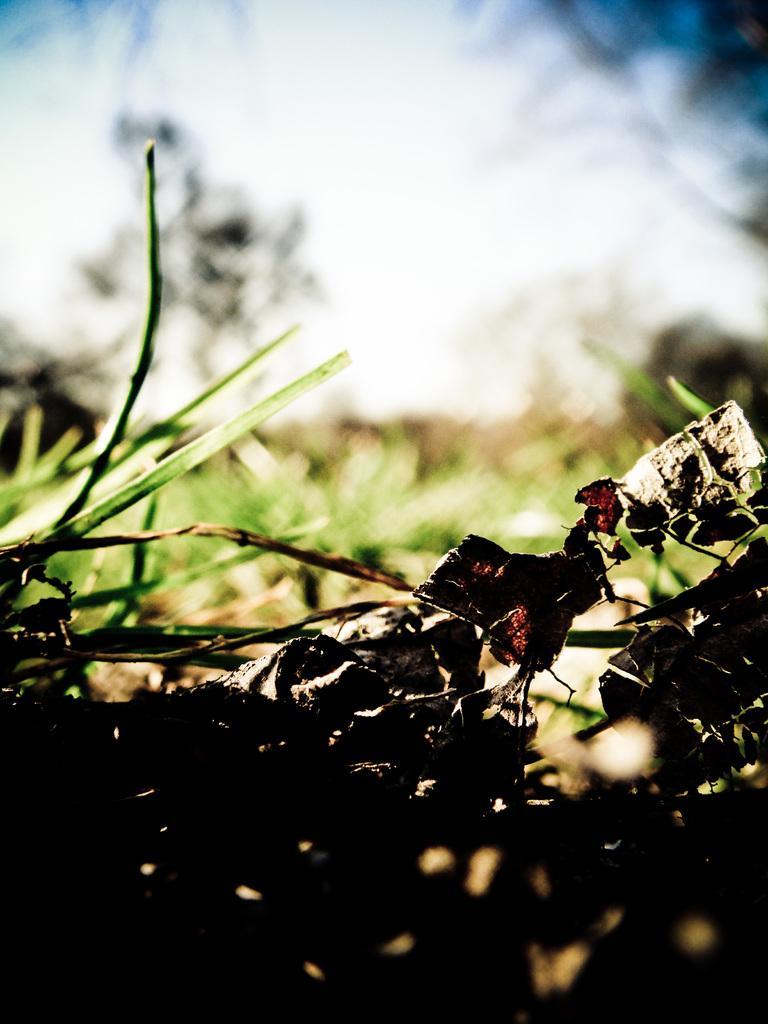Describe this image in one or two sentences. As we can see in the image there are plants, tree and sky. The image is little blurred. 